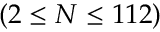Convert formula to latex. <formula><loc_0><loc_0><loc_500><loc_500>( 2 \leq N \leq 1 1 2 )</formula> 